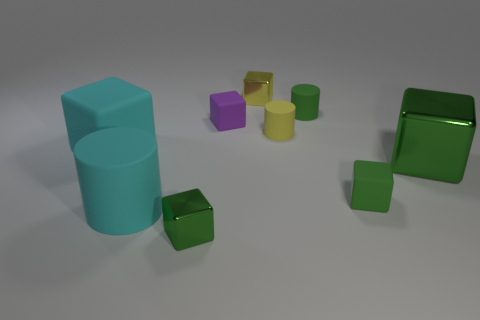What number of shiny things are to the right of the purple matte block and to the left of the big green metal thing?
Keep it short and to the point. 1. There is a small green block that is on the right side of the small yellow thing that is in front of the small purple object; how many yellow metal objects are right of it?
Give a very brief answer. 0. There is a cylinder that is the same color as the big shiny cube; what is its size?
Keep it short and to the point. Small. There is a tiny purple rubber thing; what shape is it?
Your answer should be compact. Cube. What number of other cubes are the same material as the purple block?
Provide a short and direct response. 2. There is a big thing that is made of the same material as the large cylinder; what color is it?
Offer a very short reply. Cyan. Do the purple block and the cyan rubber object that is to the right of the large rubber block have the same size?
Your answer should be very brief. No. What material is the cylinder in front of the big thing behind the big cube in front of the cyan block?
Make the answer very short. Rubber. What number of things are green cubes or large green metal objects?
Keep it short and to the point. 3. Does the metallic cube to the right of the small yellow shiny block have the same color as the rubber cube that is in front of the big matte cube?
Ensure brevity in your answer.  Yes. 